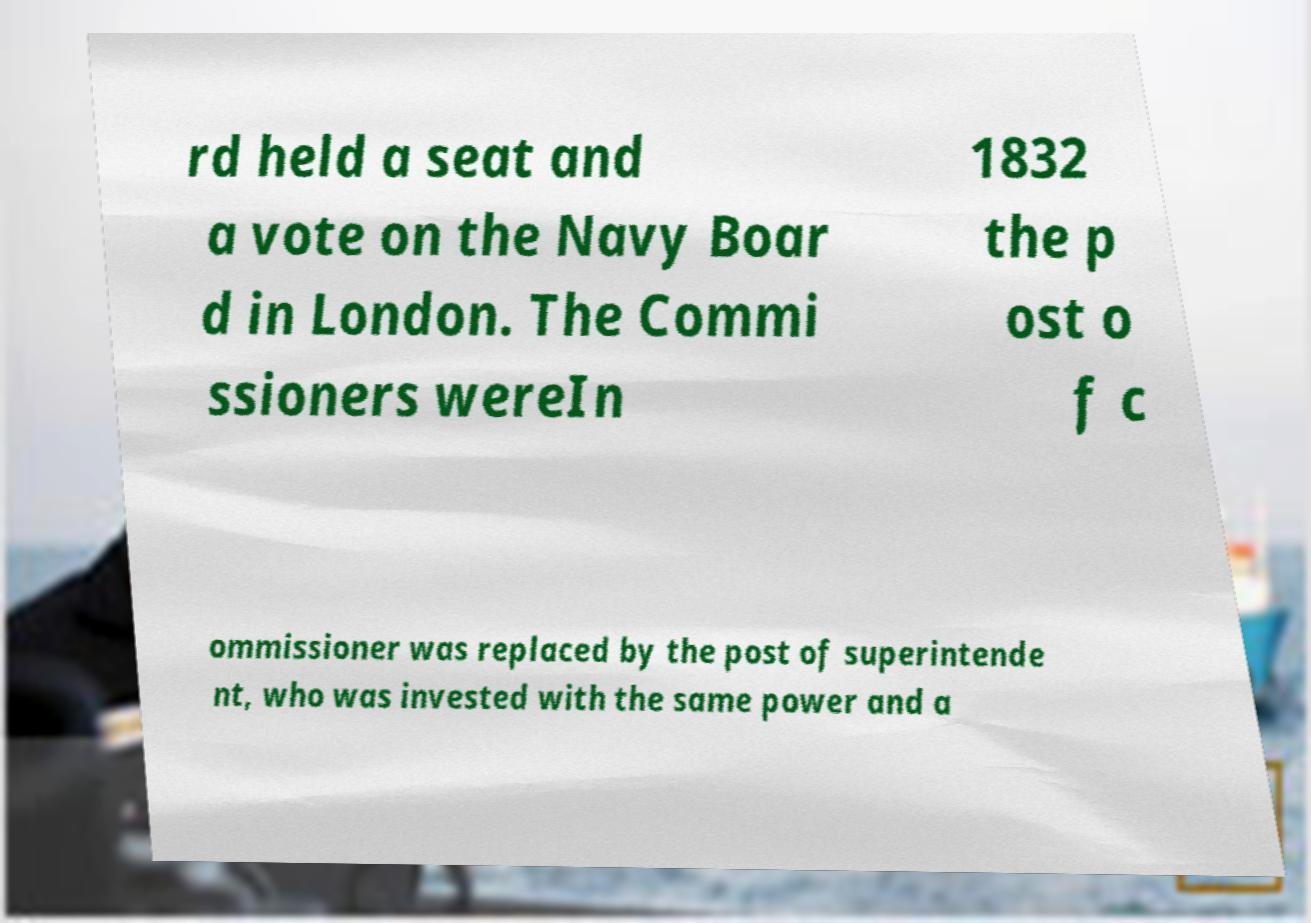Can you accurately transcribe the text from the provided image for me? rd held a seat and a vote on the Navy Boar d in London. The Commi ssioners wereIn 1832 the p ost o f c ommissioner was replaced by the post of superintende nt, who was invested with the same power and a 